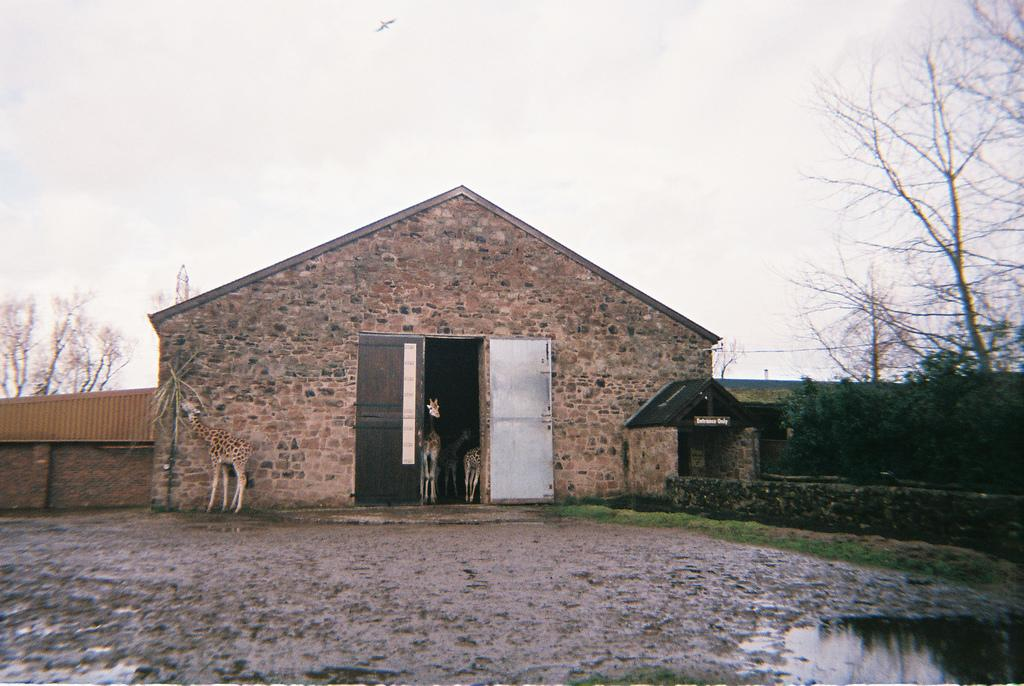What type of structure is present in the image? There is a shed in the image. What animals can be seen in the image? There are giraffes in the image. What type of barrier is visible in the image? There is a wall in the image. What type of vegetation is present in the image? There is grass in the image. What other natural elements can be seen in the image? There are trees in the image. What is visible in the background of the image? The sky is visible in the background of the image. What type of terrain is present in the image? There is water visible in the image. Where is the icicle hanging in the image? There is no icicle present in the image. What type of bread is being advertised in the image? There is no advertisement or loaf of bread present in the image. 